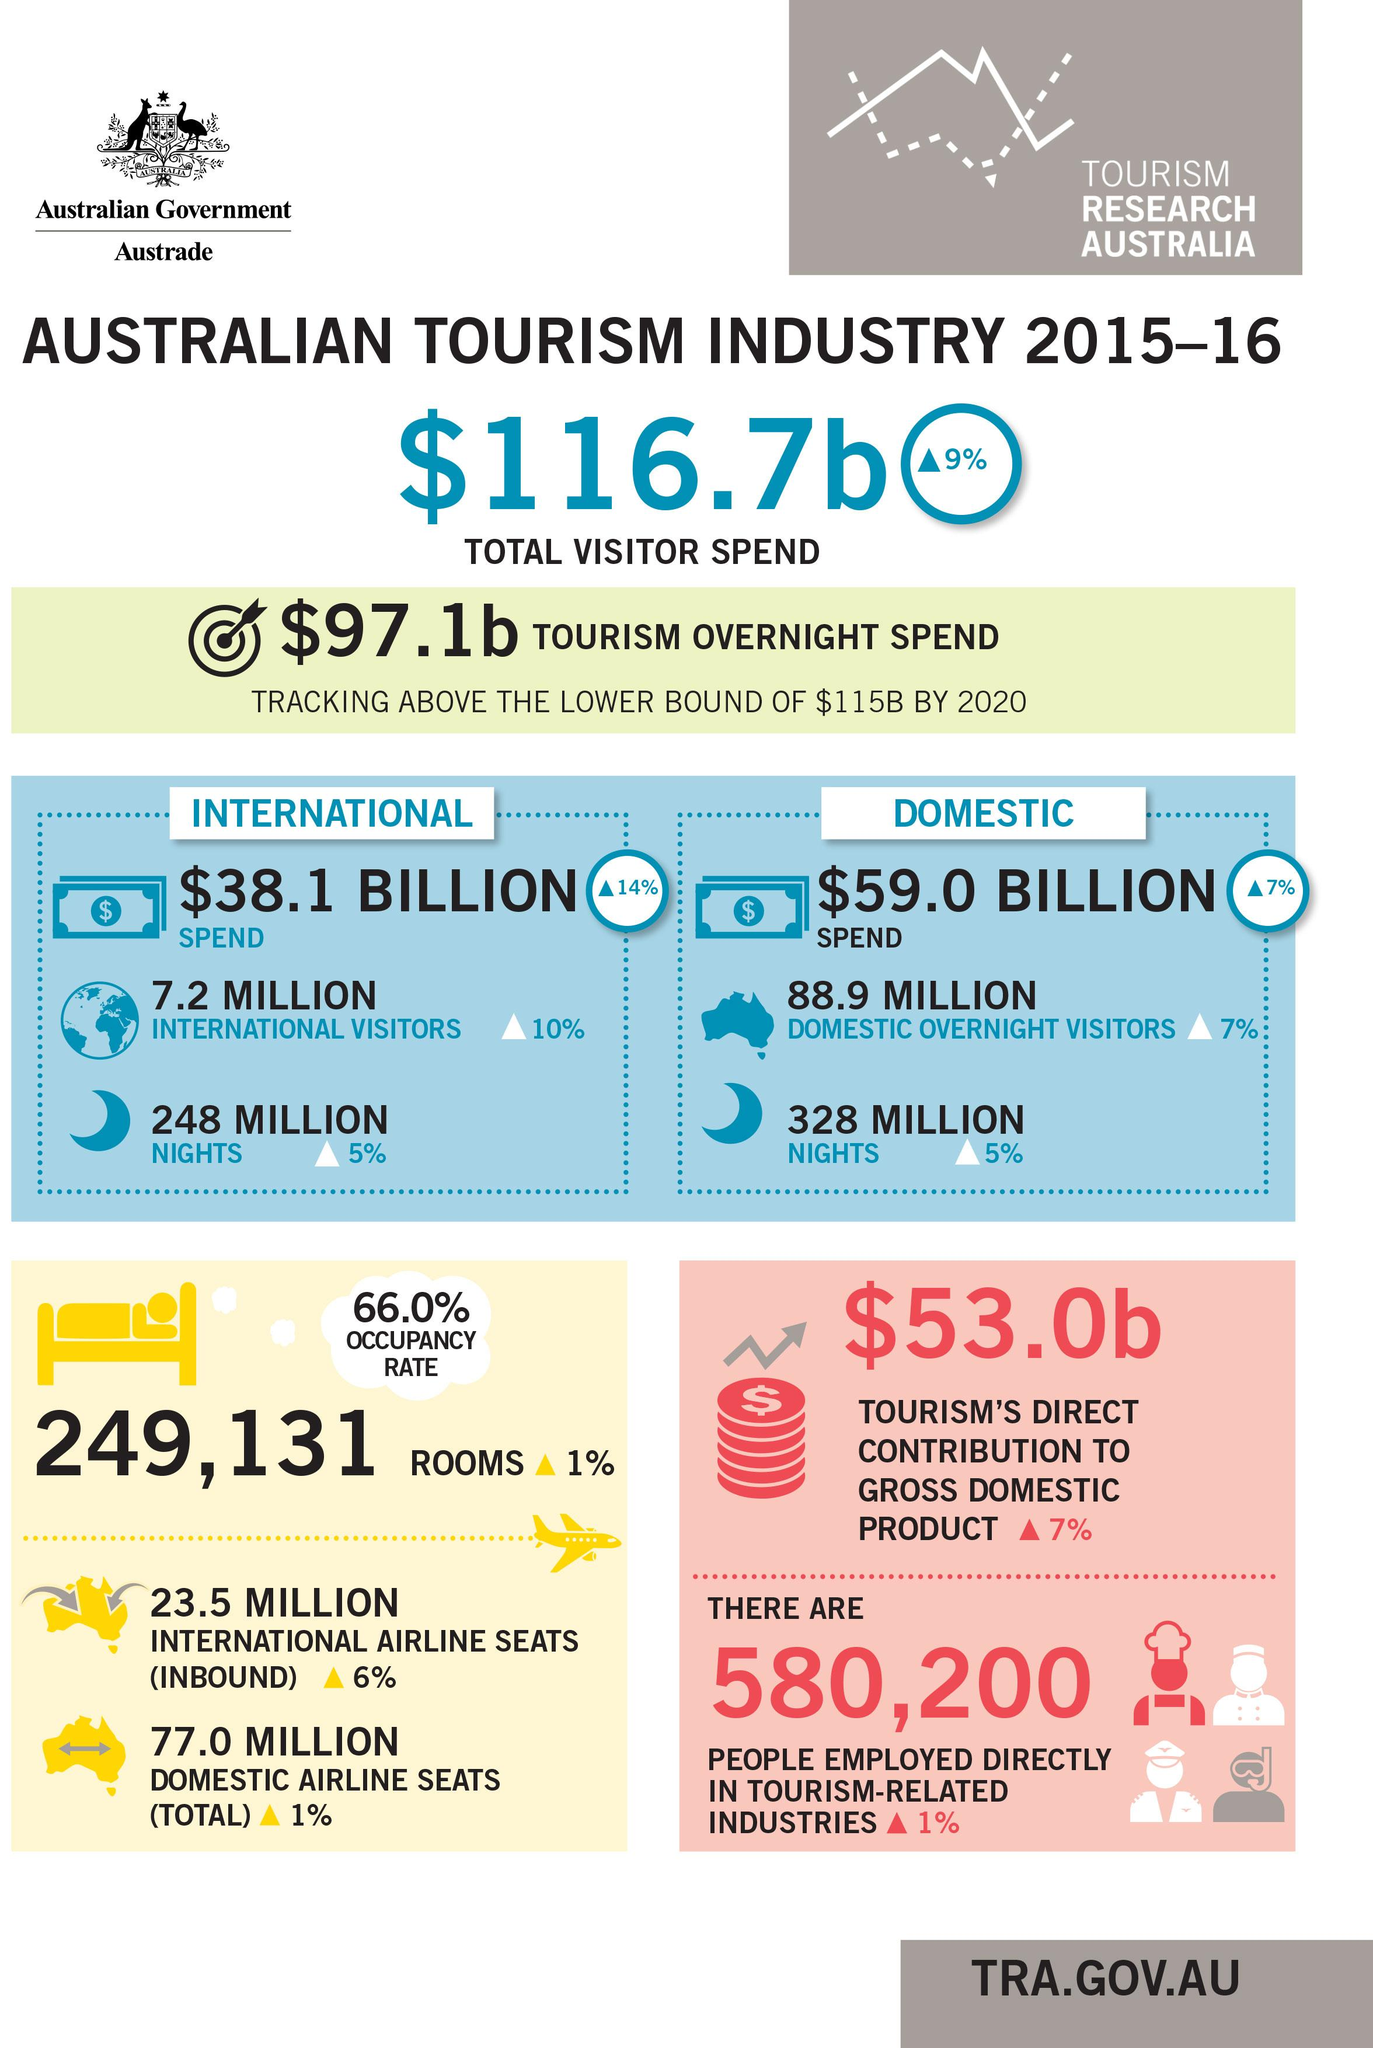Highlight a few significant elements in this photo. In 2015-2016, a record-breaking 7.2 million international tourists visited Australia. In 2015-16, the Australian tourism industry spent a total of $59.0 billion on domestic tourism. In the 2015-16 fiscal year, the Australian tourism industry spent a total of $38.1 billion on international tourism. In 2015-16, the Australian tourism industry contributed $53.0 billion to the country's Gross Domestic Product (GDP). In 2015-16, a total of 580,200 people were directly employed in tourism-related industries in Australia. 